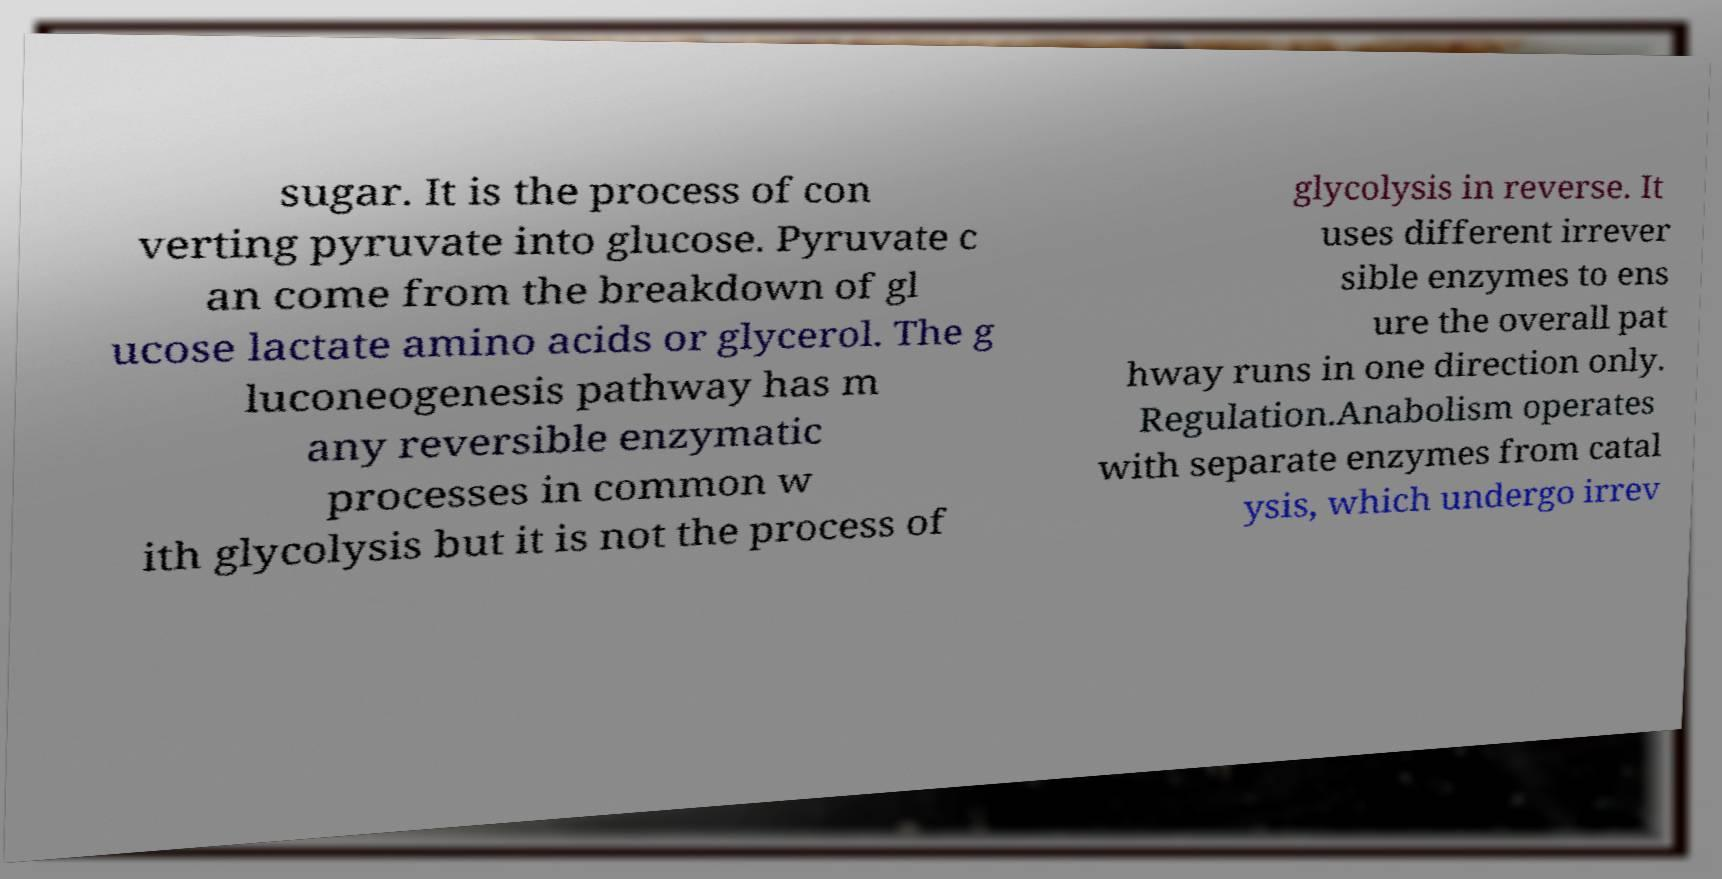Can you accurately transcribe the text from the provided image for me? sugar. It is the process of con verting pyruvate into glucose. Pyruvate c an come from the breakdown of gl ucose lactate amino acids or glycerol. The g luconeogenesis pathway has m any reversible enzymatic processes in common w ith glycolysis but it is not the process of glycolysis in reverse. It uses different irrever sible enzymes to ens ure the overall pat hway runs in one direction only. Regulation.Anabolism operates with separate enzymes from catal ysis, which undergo irrev 